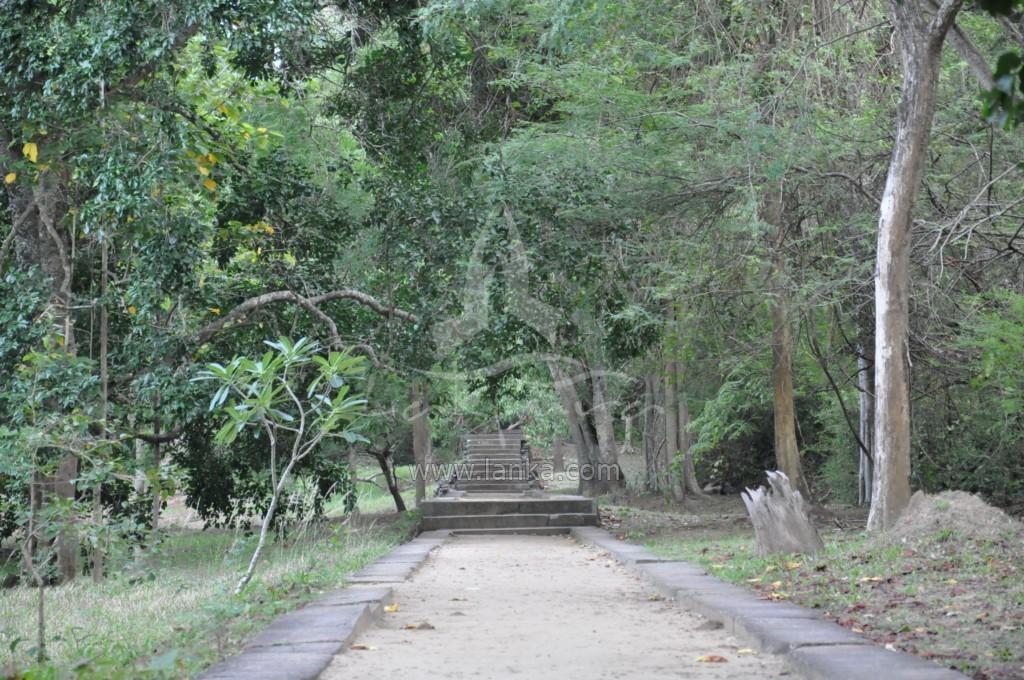Could you give a brief overview of what you see in this image? In the foreground of the picture there are dry leaves, path, plant, soil and grass. In the center of the picture there are trees, staircases and grass. 